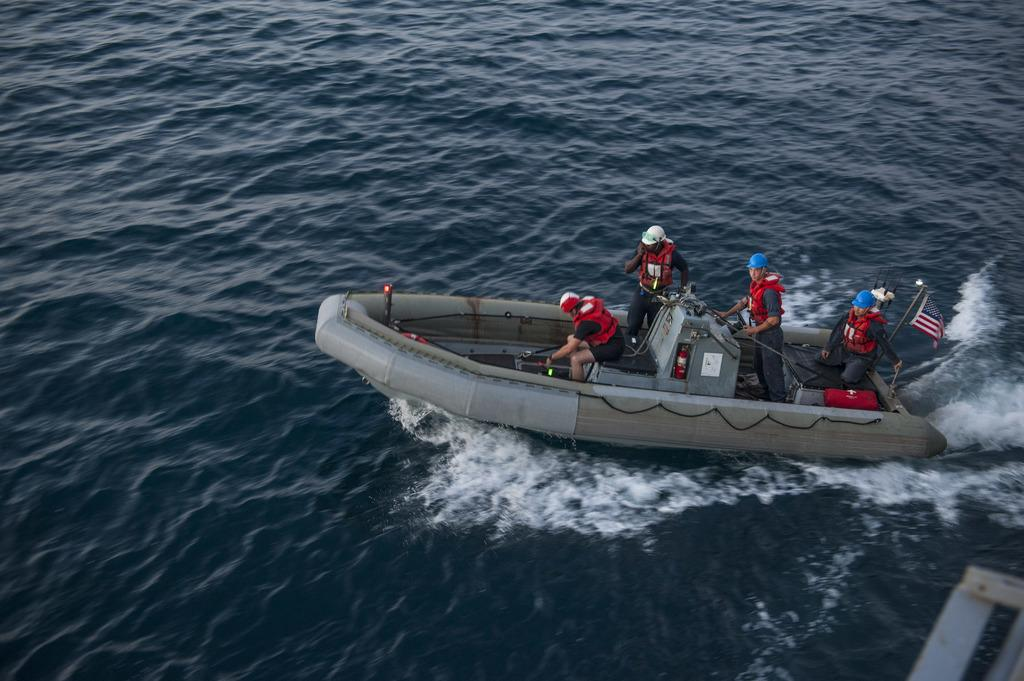What are the people in the image doing? The people in the image are in a boat. What are the people wearing in the image? The people are wearing red color jackets. What can be seen flying in the image? There is a flag visible in the image. What is the primary setting of the image? There is water in the image. What type of plantation can be seen in the image? There is no plantation present in the image; it features people in a boat on water. How many girls are visible in the image? The provided facts do not mention the gender of the people in the boat, so it cannot be determined from the image. 